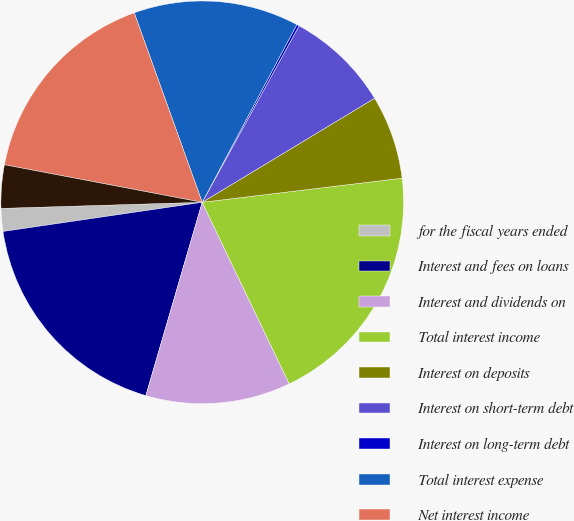Convert chart to OTSL. <chart><loc_0><loc_0><loc_500><loc_500><pie_chart><fcel>for the fiscal years ended<fcel>Interest and fees on loans<fcel>Interest and dividends on<fcel>Total interest income<fcel>Interest on deposits<fcel>Interest on short-term debt<fcel>Interest on long-term debt<fcel>Total interest expense<fcel>Net interest income<fcel>Unrealized gains (losses) on<nl><fcel>1.83%<fcel>18.17%<fcel>11.63%<fcel>19.8%<fcel>6.73%<fcel>8.37%<fcel>0.2%<fcel>13.27%<fcel>16.53%<fcel>3.47%<nl></chart> 